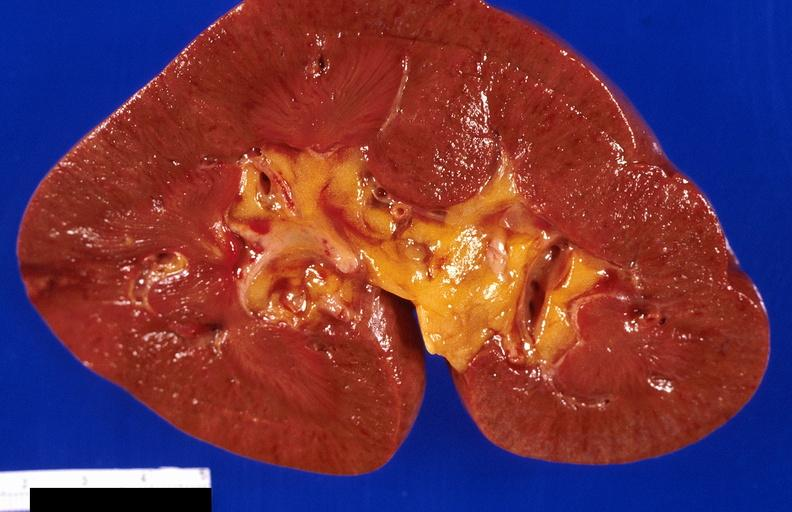does this image show kidney, infarct?
Answer the question using a single word or phrase. Yes 